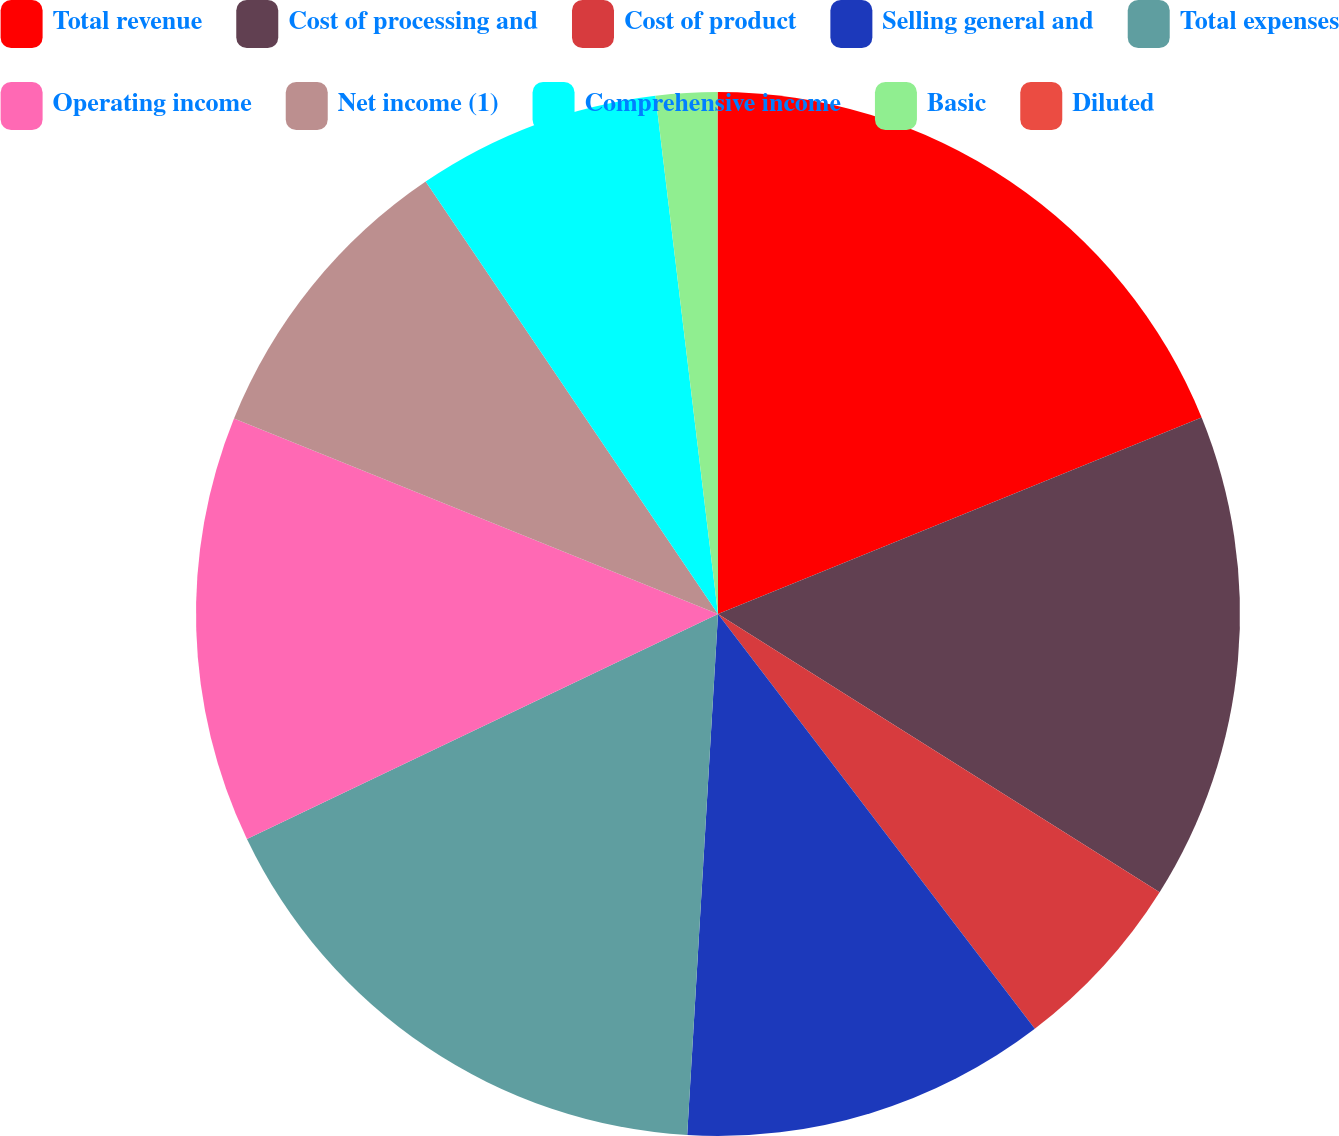Convert chart to OTSL. <chart><loc_0><loc_0><loc_500><loc_500><pie_chart><fcel>Total revenue<fcel>Cost of processing and<fcel>Cost of product<fcel>Selling general and<fcel>Total expenses<fcel>Operating income<fcel>Net income (1)<fcel>Comprehensive income<fcel>Basic<fcel>Diluted<nl><fcel>18.86%<fcel>15.09%<fcel>5.67%<fcel>11.32%<fcel>16.97%<fcel>13.2%<fcel>9.43%<fcel>7.55%<fcel>1.9%<fcel>0.01%<nl></chart> 